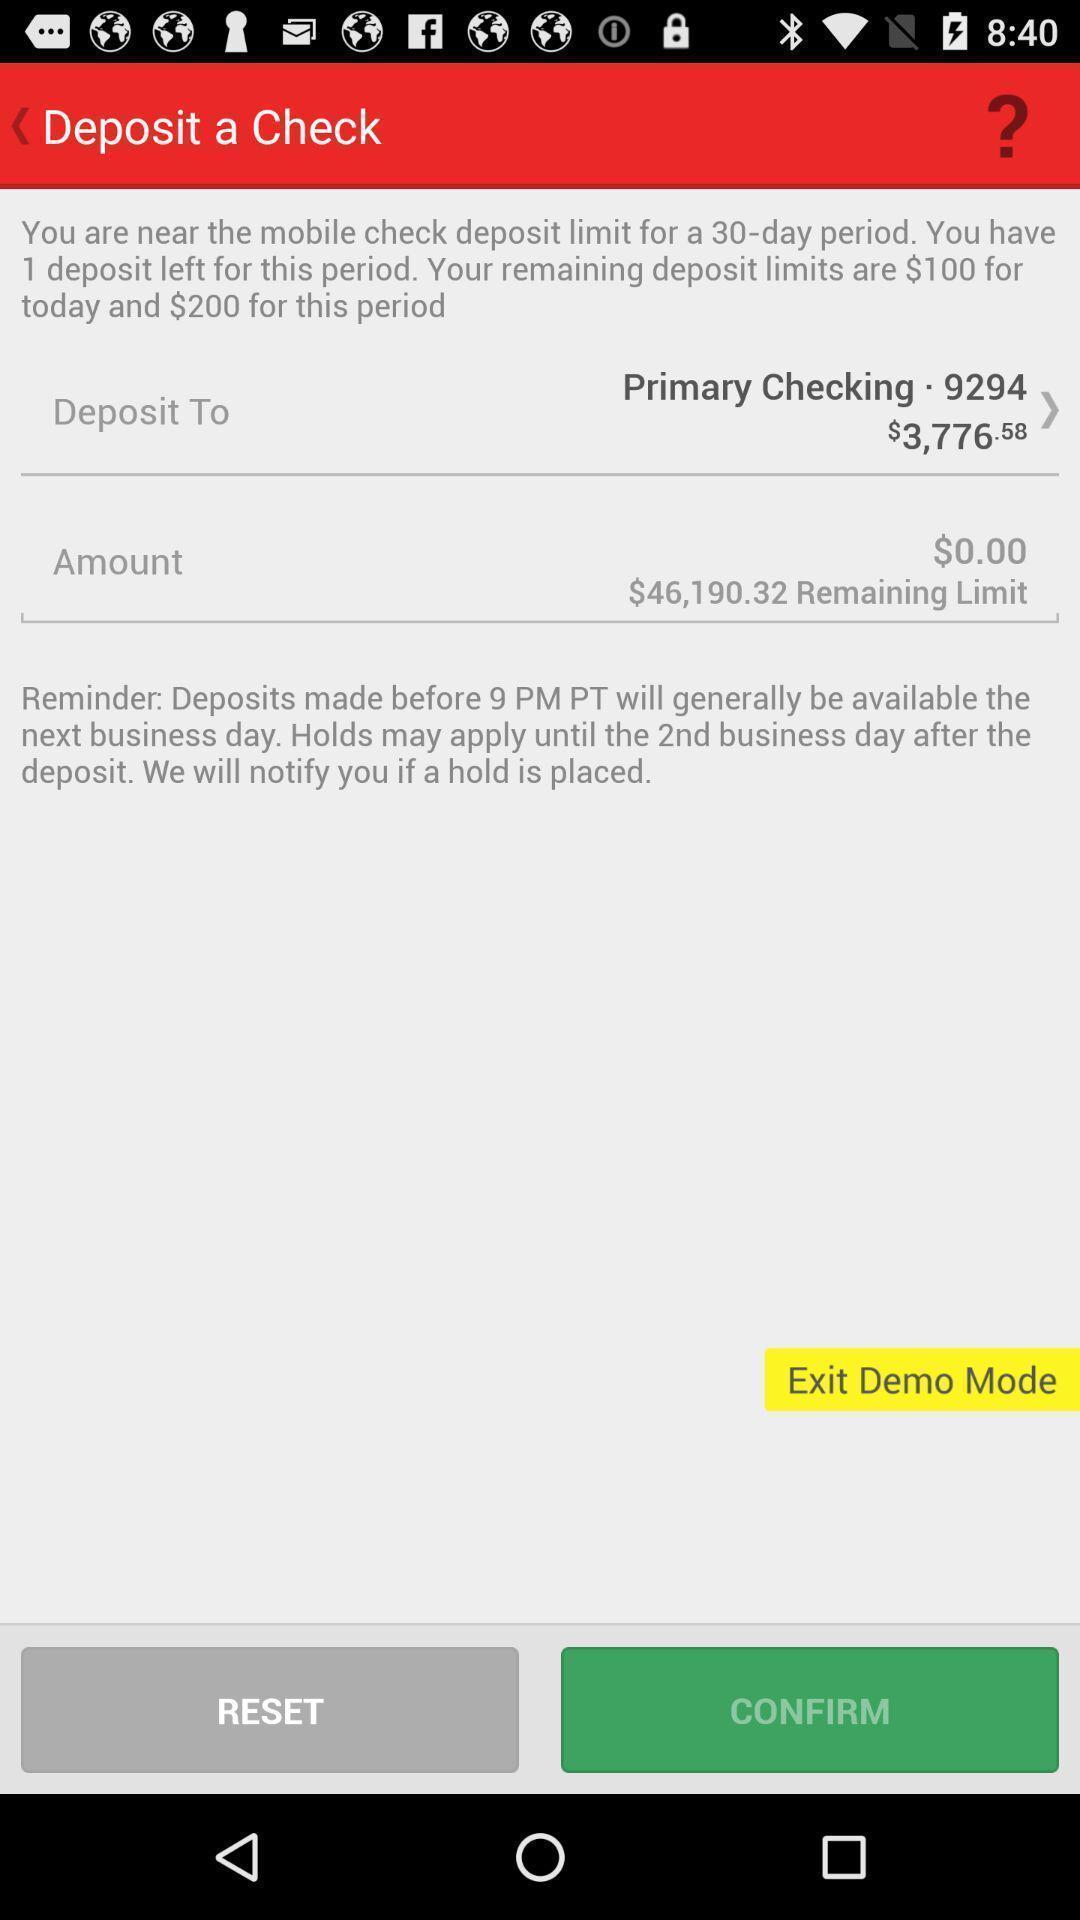Tell me about the visual elements in this screen capture. Screen is showing deposit options in an banking application. 